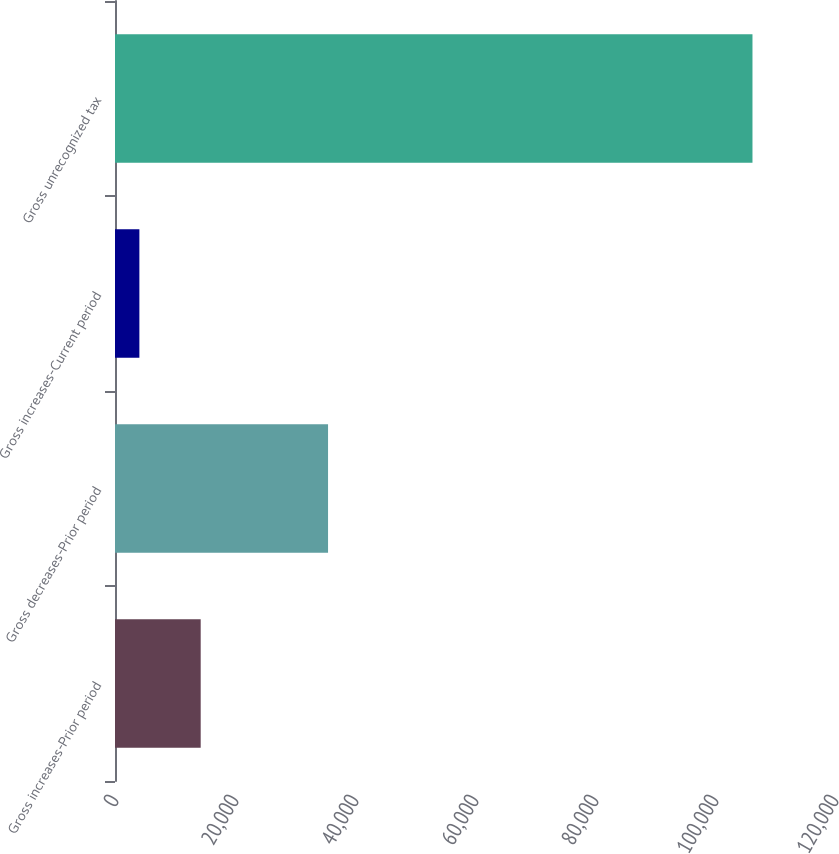Convert chart. <chart><loc_0><loc_0><loc_500><loc_500><bar_chart><fcel>Gross increases-Prior period<fcel>Gross decreases-Prior period<fcel>Gross increases-Current period<fcel>Gross unrecognized tax<nl><fcel>14282.2<fcel>35508<fcel>4064<fcel>106246<nl></chart> 